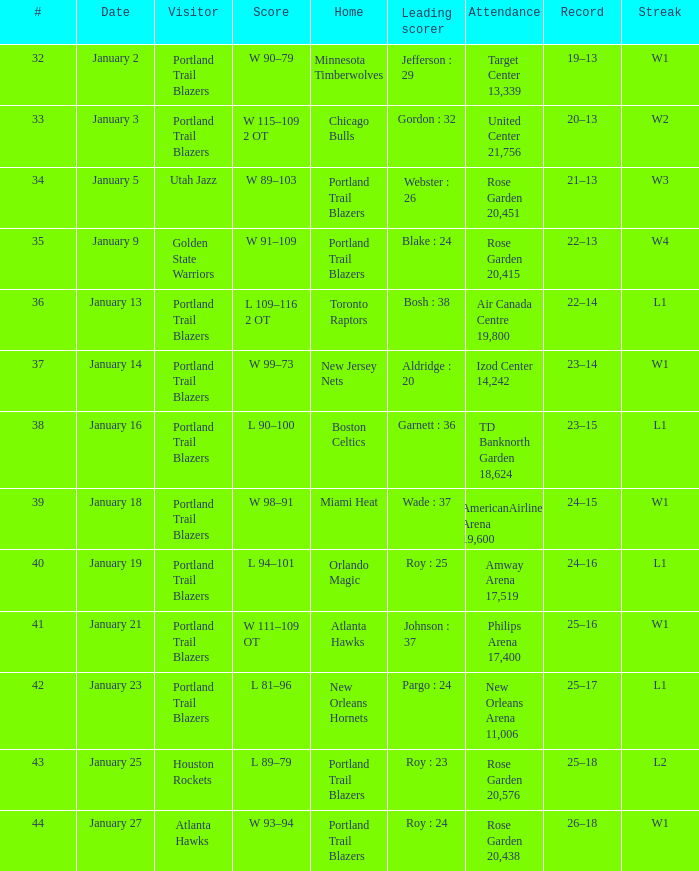How many dates in total have gordon as the scorer: 32? 1.0. 